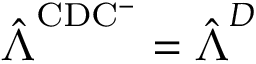<formula> <loc_0><loc_0><loc_500><loc_500>\hat { \Lambda } ^ { C D C ^ { - } } = \hat { \Lambda } ^ { D }</formula> 